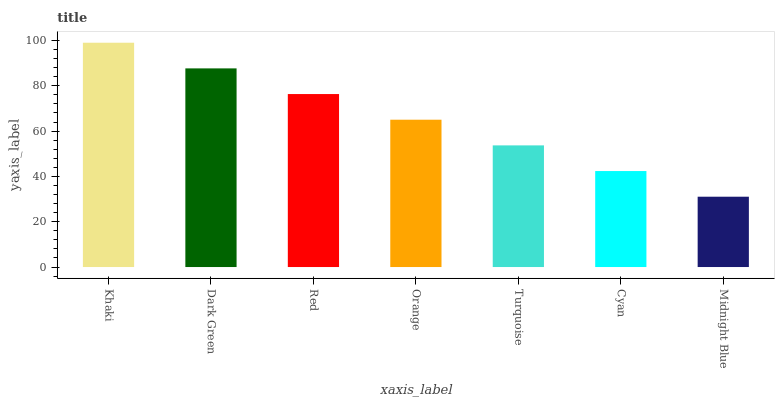Is Dark Green the minimum?
Answer yes or no. No. Is Dark Green the maximum?
Answer yes or no. No. Is Khaki greater than Dark Green?
Answer yes or no. Yes. Is Dark Green less than Khaki?
Answer yes or no. Yes. Is Dark Green greater than Khaki?
Answer yes or no. No. Is Khaki less than Dark Green?
Answer yes or no. No. Is Orange the high median?
Answer yes or no. Yes. Is Orange the low median?
Answer yes or no. Yes. Is Khaki the high median?
Answer yes or no. No. Is Red the low median?
Answer yes or no. No. 